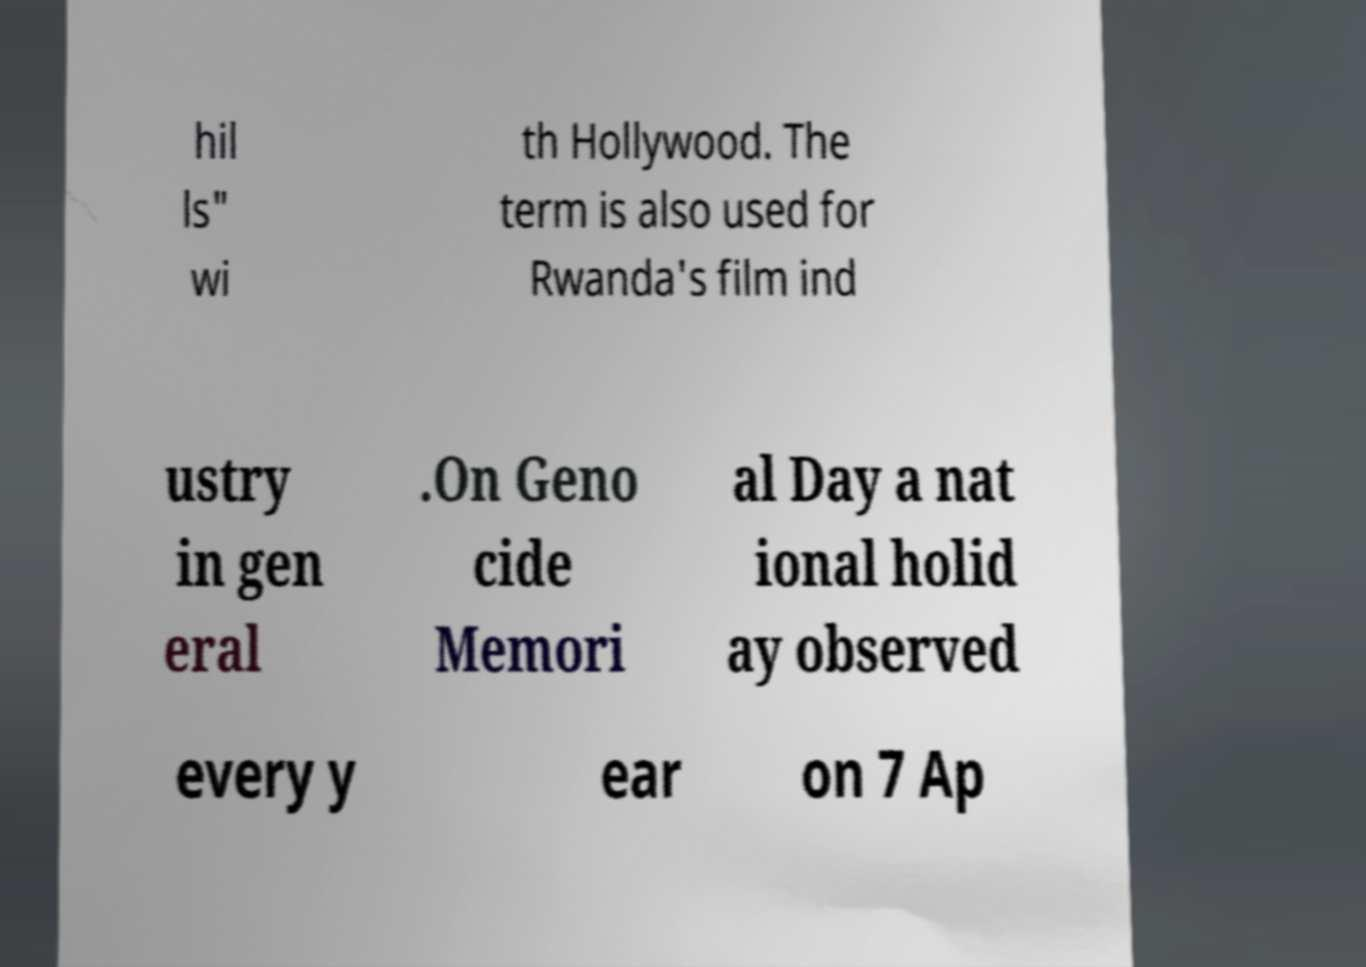Can you accurately transcribe the text from the provided image for me? hil ls" wi th Hollywood. The term is also used for Rwanda's film ind ustry in gen eral .On Geno cide Memori al Day a nat ional holid ay observed every y ear on 7 Ap 